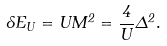<formula> <loc_0><loc_0><loc_500><loc_500>\delta E _ { U } = U M ^ { 2 } = \frac { 4 } { U } \Delta ^ { 2 } .</formula> 